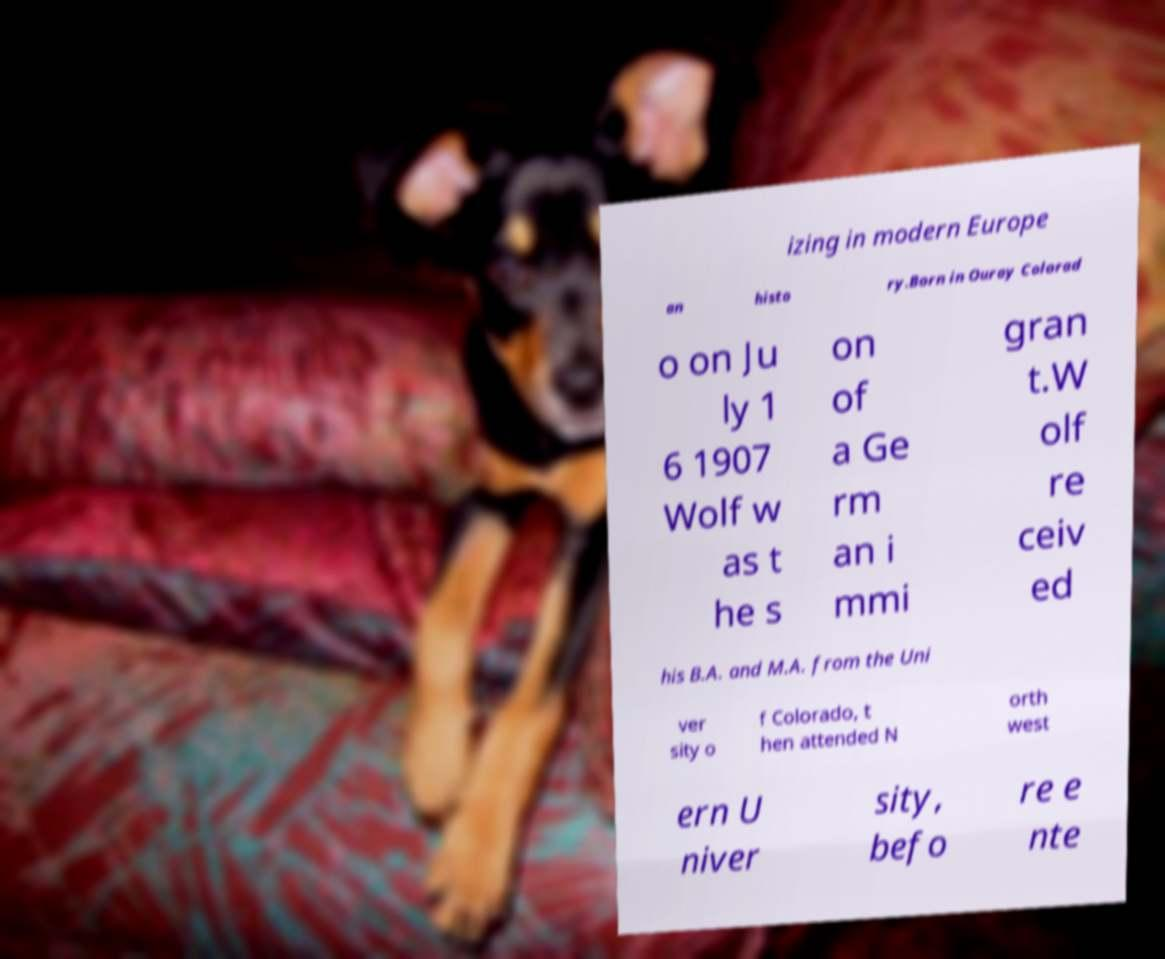Could you extract and type out the text from this image? izing in modern Europe an histo ry.Born in Ouray Colorad o on Ju ly 1 6 1907 Wolf w as t he s on of a Ge rm an i mmi gran t.W olf re ceiv ed his B.A. and M.A. from the Uni ver sity o f Colorado, t hen attended N orth west ern U niver sity, befo re e nte 